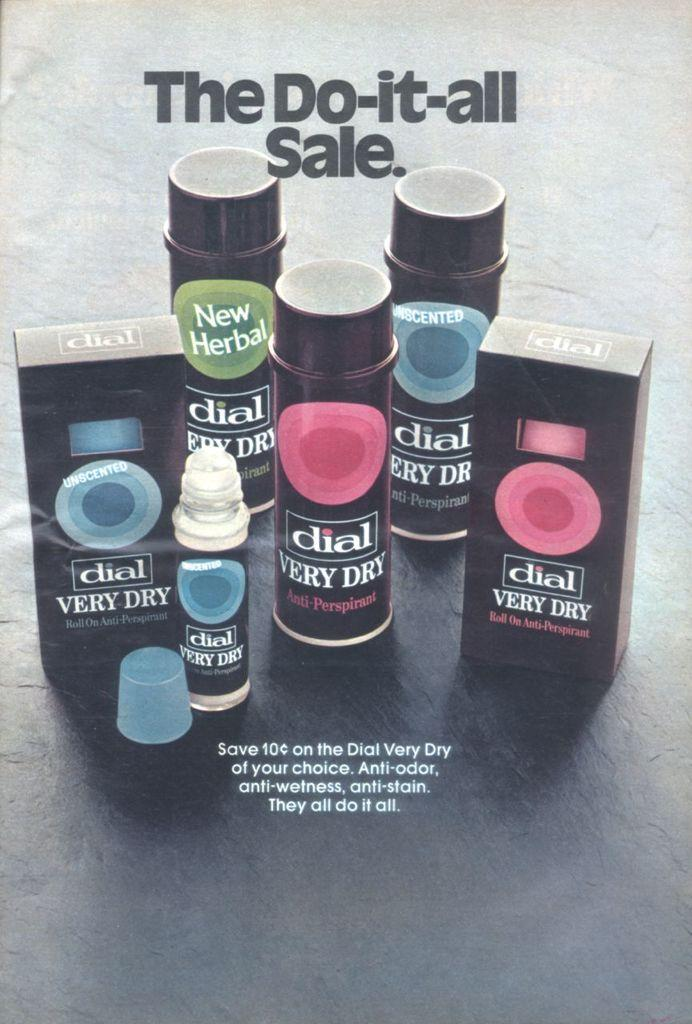<image>
Describe the image concisely. Different Anti-Odor fragrances from Dial that say Very Dry, and the slogan: The Do-It-All-Sale. 